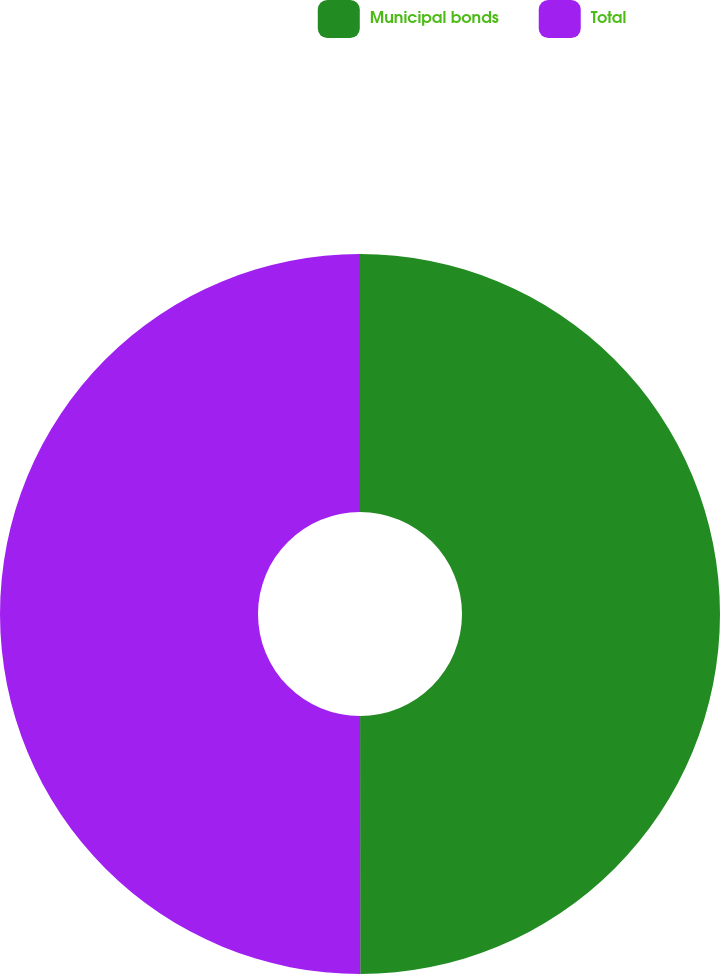Convert chart. <chart><loc_0><loc_0><loc_500><loc_500><pie_chart><fcel>Municipal bonds<fcel>Total<nl><fcel>49.99%<fcel>50.01%<nl></chart> 